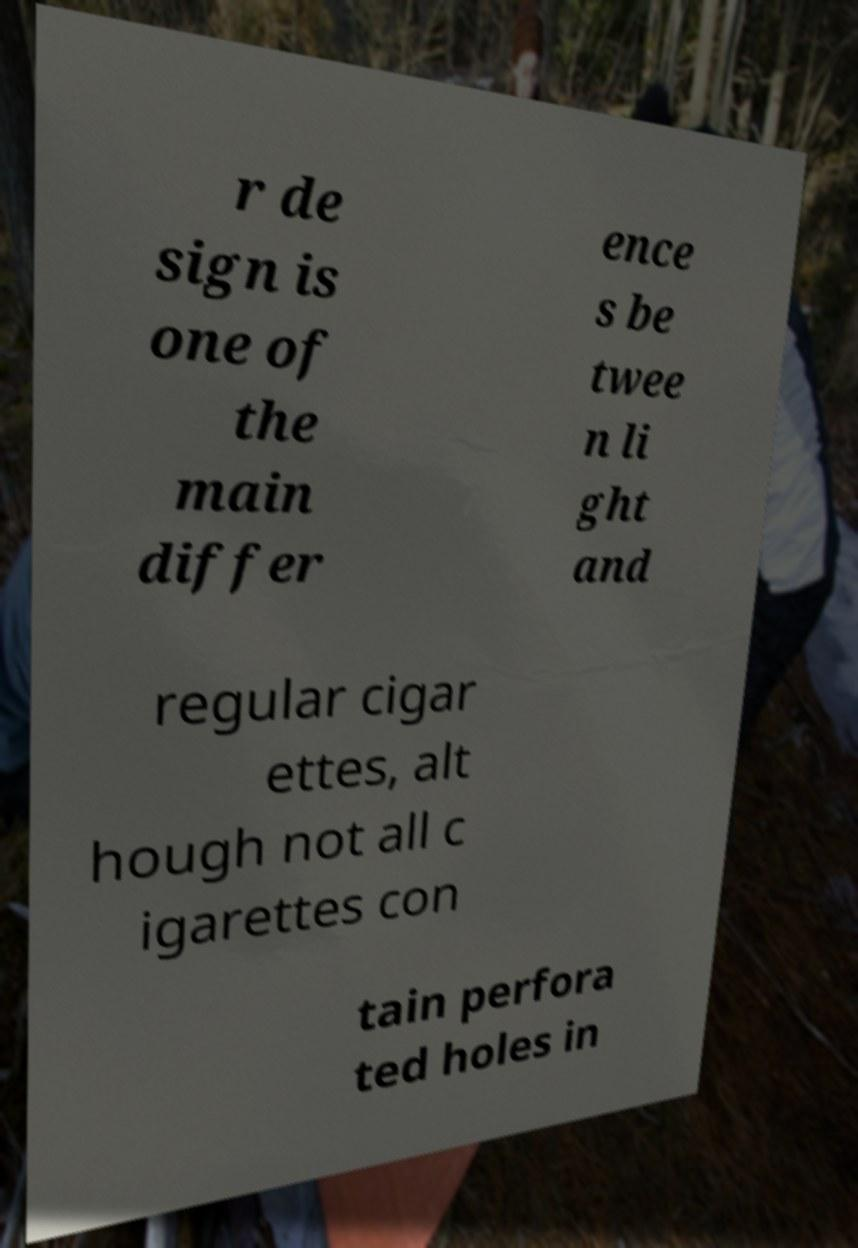I need the written content from this picture converted into text. Can you do that? r de sign is one of the main differ ence s be twee n li ght and regular cigar ettes, alt hough not all c igarettes con tain perfora ted holes in 